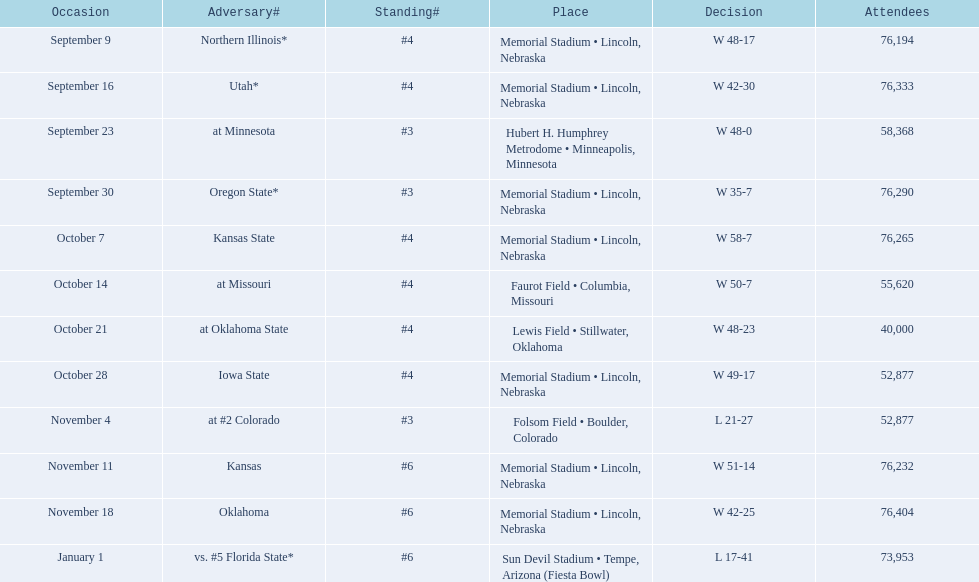On average how many times was w listed as the result? 10. Write the full table. {'header': ['Occasion', 'Adversary#', 'Standing#', 'Place', 'Decision', 'Attendees'], 'rows': [['September 9', 'Northern Illinois*', '#4', 'Memorial Stadium • Lincoln, Nebraska', 'W\xa048-17', '76,194'], ['September 16', 'Utah*', '#4', 'Memorial Stadium • Lincoln, Nebraska', 'W\xa042-30', '76,333'], ['September 23', 'at\xa0Minnesota', '#3', 'Hubert H. Humphrey Metrodome • Minneapolis, Minnesota', 'W\xa048-0', '58,368'], ['September 30', 'Oregon State*', '#3', 'Memorial Stadium • Lincoln, Nebraska', 'W\xa035-7', '76,290'], ['October 7', 'Kansas State', '#4', 'Memorial Stadium • Lincoln, Nebraska', 'W\xa058-7', '76,265'], ['October 14', 'at\xa0Missouri', '#4', 'Faurot Field • Columbia, Missouri', 'W\xa050-7', '55,620'], ['October 21', 'at\xa0Oklahoma State', '#4', 'Lewis Field • Stillwater, Oklahoma', 'W\xa048-23', '40,000'], ['October 28', 'Iowa State', '#4', 'Memorial Stadium • Lincoln, Nebraska', 'W\xa049-17', '52,877'], ['November 4', 'at\xa0#2\xa0Colorado', '#3', 'Folsom Field • Boulder, Colorado', 'L\xa021-27', '52,877'], ['November 11', 'Kansas', '#6', 'Memorial Stadium • Lincoln, Nebraska', 'W\xa051-14', '76,232'], ['November 18', 'Oklahoma', '#6', 'Memorial Stadium • Lincoln, Nebraska', 'W\xa042-25', '76,404'], ['January 1', 'vs.\xa0#5\xa0Florida State*', '#6', 'Sun Devil Stadium • Tempe, Arizona (Fiesta Bowl)', 'L\xa017-41', '73,953']]} 